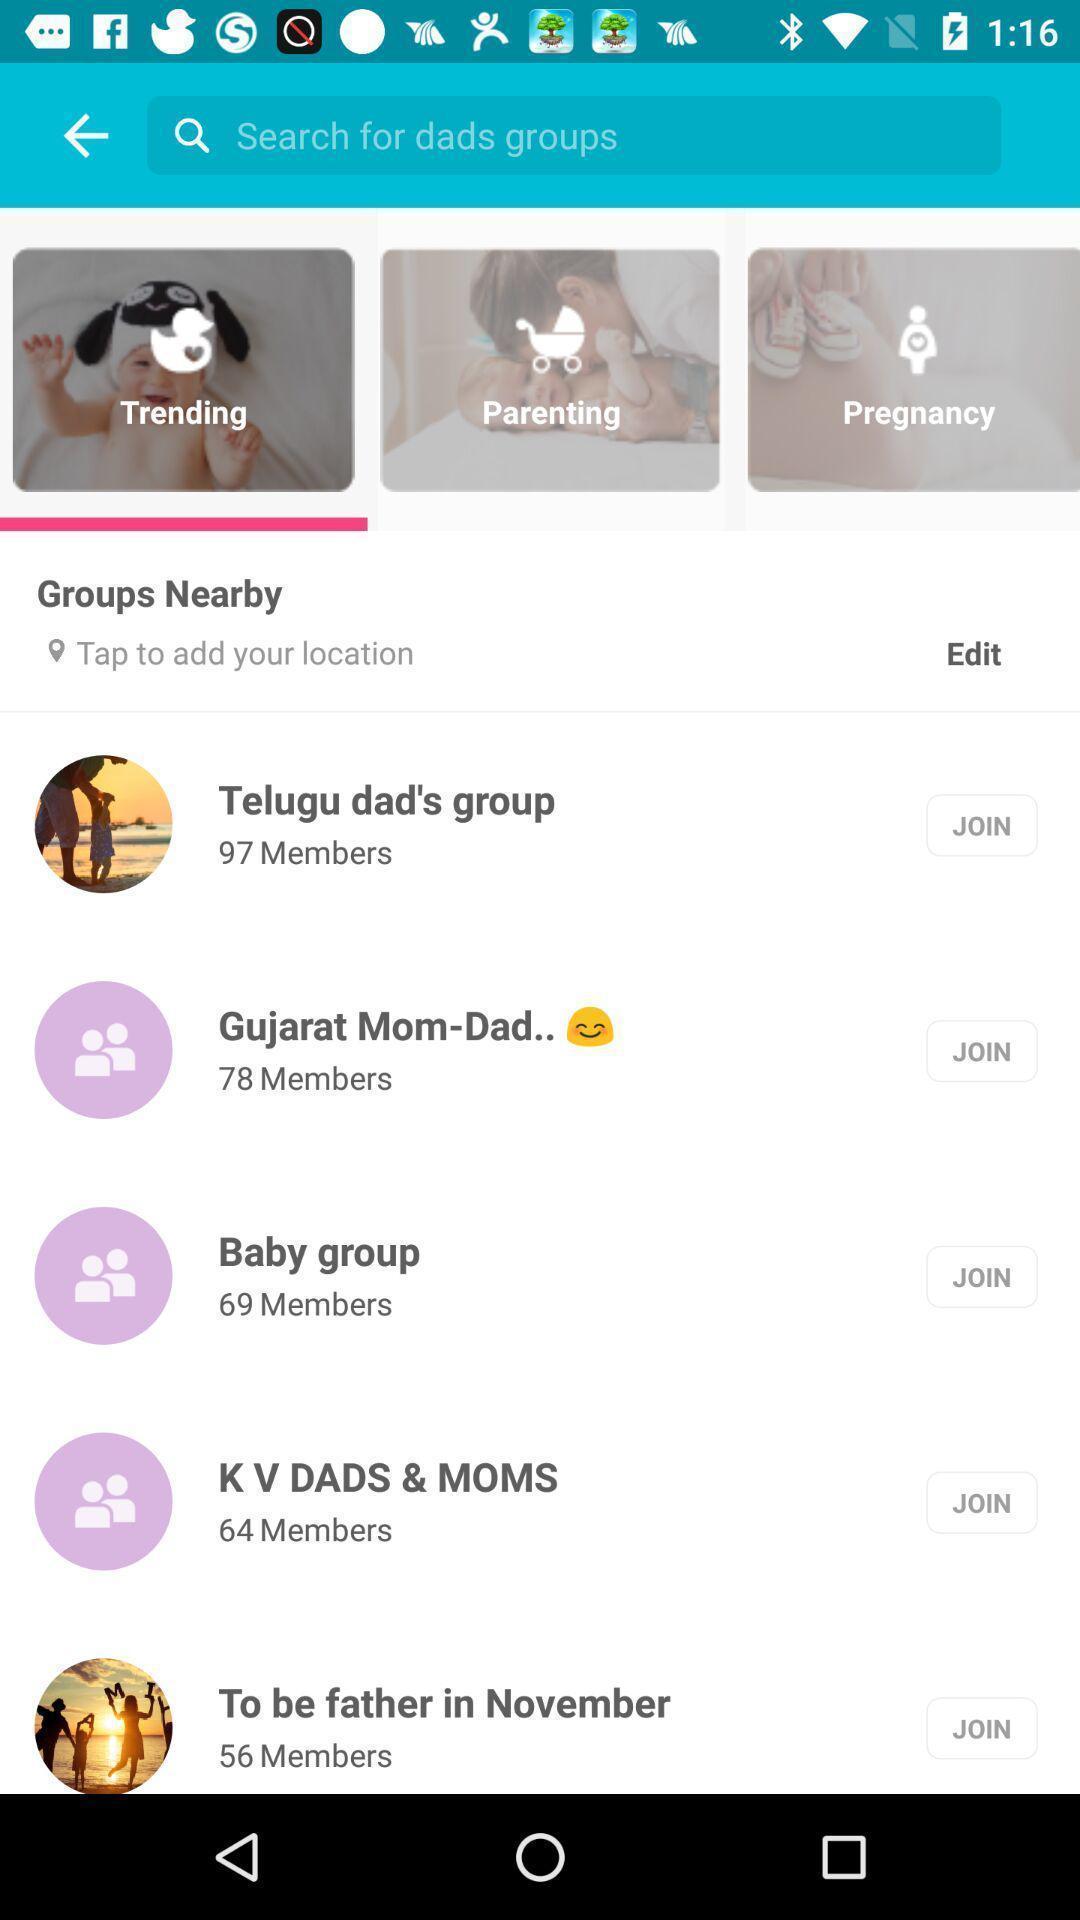Tell me what you see in this picture. Page showing the options in trending tab. 